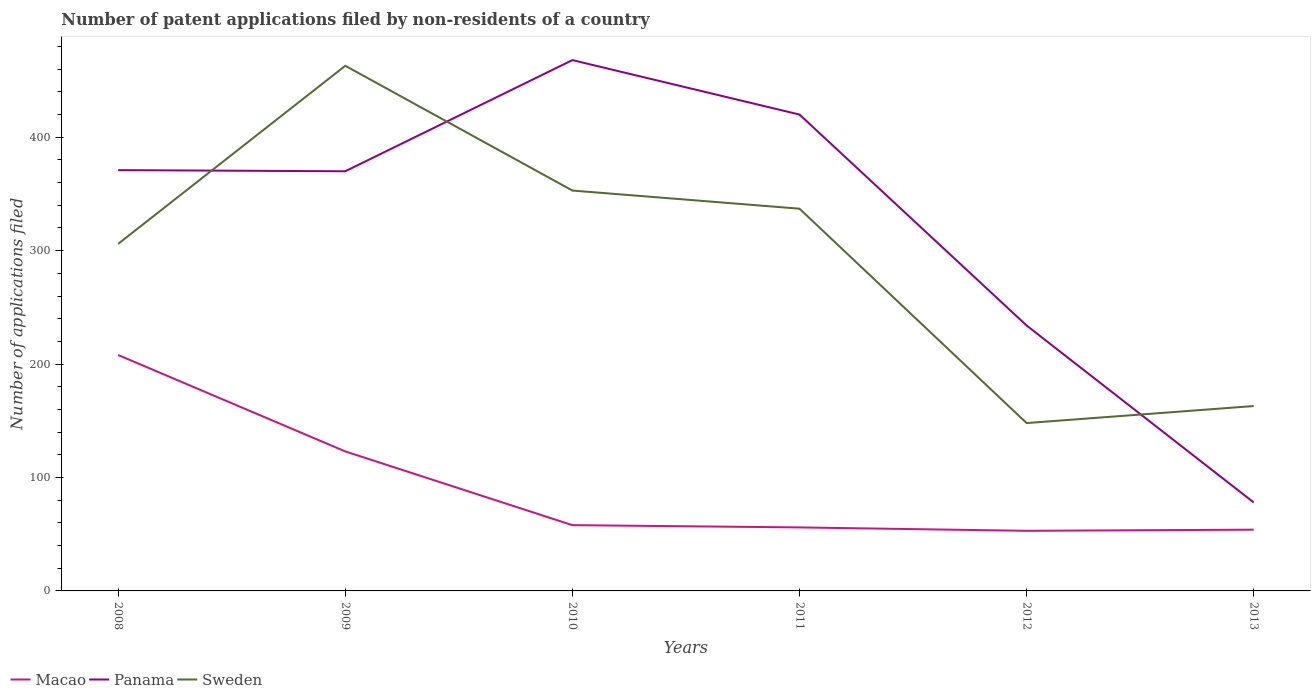Is the number of lines equal to the number of legend labels?
Offer a very short reply. Yes. Across all years, what is the maximum number of applications filed in Panama?
Offer a very short reply. 78. What is the total number of applications filed in Sweden in the graph?
Provide a short and direct response. 16. What is the difference between the highest and the second highest number of applications filed in Sweden?
Your answer should be very brief. 315. What is the difference between the highest and the lowest number of applications filed in Sweden?
Your answer should be compact. 4. How many years are there in the graph?
Your answer should be very brief. 6. Are the values on the major ticks of Y-axis written in scientific E-notation?
Make the answer very short. No. Does the graph contain any zero values?
Give a very brief answer. No. Where does the legend appear in the graph?
Provide a succinct answer. Bottom left. What is the title of the graph?
Offer a terse response. Number of patent applications filed by non-residents of a country. Does "Latvia" appear as one of the legend labels in the graph?
Give a very brief answer. No. What is the label or title of the Y-axis?
Ensure brevity in your answer.  Number of applications filed. What is the Number of applications filed of Macao in 2008?
Your response must be concise. 208. What is the Number of applications filed in Panama in 2008?
Provide a succinct answer. 371. What is the Number of applications filed of Sweden in 2008?
Make the answer very short. 306. What is the Number of applications filed of Macao in 2009?
Offer a terse response. 123. What is the Number of applications filed of Panama in 2009?
Your answer should be compact. 370. What is the Number of applications filed in Sweden in 2009?
Provide a succinct answer. 463. What is the Number of applications filed in Macao in 2010?
Offer a very short reply. 58. What is the Number of applications filed in Panama in 2010?
Your answer should be very brief. 468. What is the Number of applications filed of Sweden in 2010?
Ensure brevity in your answer.  353. What is the Number of applications filed in Panama in 2011?
Ensure brevity in your answer.  420. What is the Number of applications filed in Sweden in 2011?
Your answer should be very brief. 337. What is the Number of applications filed of Macao in 2012?
Provide a short and direct response. 53. What is the Number of applications filed in Panama in 2012?
Ensure brevity in your answer.  234. What is the Number of applications filed of Sweden in 2012?
Your answer should be very brief. 148. What is the Number of applications filed in Macao in 2013?
Make the answer very short. 54. What is the Number of applications filed of Sweden in 2013?
Your answer should be compact. 163. Across all years, what is the maximum Number of applications filed in Macao?
Provide a short and direct response. 208. Across all years, what is the maximum Number of applications filed in Panama?
Keep it short and to the point. 468. Across all years, what is the maximum Number of applications filed in Sweden?
Your answer should be compact. 463. Across all years, what is the minimum Number of applications filed of Sweden?
Offer a terse response. 148. What is the total Number of applications filed of Macao in the graph?
Your response must be concise. 552. What is the total Number of applications filed in Panama in the graph?
Give a very brief answer. 1941. What is the total Number of applications filed in Sweden in the graph?
Give a very brief answer. 1770. What is the difference between the Number of applications filed in Panama in 2008 and that in 2009?
Your answer should be very brief. 1. What is the difference between the Number of applications filed of Sweden in 2008 and that in 2009?
Ensure brevity in your answer.  -157. What is the difference between the Number of applications filed in Macao in 2008 and that in 2010?
Provide a succinct answer. 150. What is the difference between the Number of applications filed of Panama in 2008 and that in 2010?
Offer a very short reply. -97. What is the difference between the Number of applications filed of Sweden in 2008 and that in 2010?
Make the answer very short. -47. What is the difference between the Number of applications filed of Macao in 2008 and that in 2011?
Provide a succinct answer. 152. What is the difference between the Number of applications filed of Panama in 2008 and that in 2011?
Provide a short and direct response. -49. What is the difference between the Number of applications filed of Sweden in 2008 and that in 2011?
Offer a very short reply. -31. What is the difference between the Number of applications filed of Macao in 2008 and that in 2012?
Give a very brief answer. 155. What is the difference between the Number of applications filed of Panama in 2008 and that in 2012?
Make the answer very short. 137. What is the difference between the Number of applications filed in Sweden in 2008 and that in 2012?
Provide a short and direct response. 158. What is the difference between the Number of applications filed of Macao in 2008 and that in 2013?
Your answer should be compact. 154. What is the difference between the Number of applications filed of Panama in 2008 and that in 2013?
Offer a terse response. 293. What is the difference between the Number of applications filed in Sweden in 2008 and that in 2013?
Your answer should be very brief. 143. What is the difference between the Number of applications filed in Macao in 2009 and that in 2010?
Your response must be concise. 65. What is the difference between the Number of applications filed of Panama in 2009 and that in 2010?
Provide a short and direct response. -98. What is the difference between the Number of applications filed in Sweden in 2009 and that in 2010?
Keep it short and to the point. 110. What is the difference between the Number of applications filed in Macao in 2009 and that in 2011?
Provide a short and direct response. 67. What is the difference between the Number of applications filed of Panama in 2009 and that in 2011?
Your response must be concise. -50. What is the difference between the Number of applications filed of Sweden in 2009 and that in 2011?
Provide a succinct answer. 126. What is the difference between the Number of applications filed in Macao in 2009 and that in 2012?
Offer a very short reply. 70. What is the difference between the Number of applications filed of Panama in 2009 and that in 2012?
Give a very brief answer. 136. What is the difference between the Number of applications filed in Sweden in 2009 and that in 2012?
Your answer should be very brief. 315. What is the difference between the Number of applications filed in Macao in 2009 and that in 2013?
Provide a succinct answer. 69. What is the difference between the Number of applications filed of Panama in 2009 and that in 2013?
Your answer should be very brief. 292. What is the difference between the Number of applications filed of Sweden in 2009 and that in 2013?
Your answer should be compact. 300. What is the difference between the Number of applications filed of Macao in 2010 and that in 2011?
Your answer should be compact. 2. What is the difference between the Number of applications filed in Panama in 2010 and that in 2011?
Keep it short and to the point. 48. What is the difference between the Number of applications filed of Macao in 2010 and that in 2012?
Your response must be concise. 5. What is the difference between the Number of applications filed in Panama in 2010 and that in 2012?
Ensure brevity in your answer.  234. What is the difference between the Number of applications filed in Sweden in 2010 and that in 2012?
Give a very brief answer. 205. What is the difference between the Number of applications filed in Panama in 2010 and that in 2013?
Your answer should be very brief. 390. What is the difference between the Number of applications filed of Sweden in 2010 and that in 2013?
Your answer should be compact. 190. What is the difference between the Number of applications filed of Macao in 2011 and that in 2012?
Offer a very short reply. 3. What is the difference between the Number of applications filed of Panama in 2011 and that in 2012?
Keep it short and to the point. 186. What is the difference between the Number of applications filed in Sweden in 2011 and that in 2012?
Give a very brief answer. 189. What is the difference between the Number of applications filed of Macao in 2011 and that in 2013?
Offer a terse response. 2. What is the difference between the Number of applications filed of Panama in 2011 and that in 2013?
Your answer should be compact. 342. What is the difference between the Number of applications filed in Sweden in 2011 and that in 2013?
Keep it short and to the point. 174. What is the difference between the Number of applications filed of Macao in 2012 and that in 2013?
Offer a terse response. -1. What is the difference between the Number of applications filed of Panama in 2012 and that in 2013?
Provide a short and direct response. 156. What is the difference between the Number of applications filed in Sweden in 2012 and that in 2013?
Your answer should be very brief. -15. What is the difference between the Number of applications filed of Macao in 2008 and the Number of applications filed of Panama in 2009?
Give a very brief answer. -162. What is the difference between the Number of applications filed in Macao in 2008 and the Number of applications filed in Sweden in 2009?
Provide a succinct answer. -255. What is the difference between the Number of applications filed of Panama in 2008 and the Number of applications filed of Sweden in 2009?
Offer a terse response. -92. What is the difference between the Number of applications filed in Macao in 2008 and the Number of applications filed in Panama in 2010?
Provide a short and direct response. -260. What is the difference between the Number of applications filed in Macao in 2008 and the Number of applications filed in Sweden in 2010?
Keep it short and to the point. -145. What is the difference between the Number of applications filed of Macao in 2008 and the Number of applications filed of Panama in 2011?
Your answer should be compact. -212. What is the difference between the Number of applications filed in Macao in 2008 and the Number of applications filed in Sweden in 2011?
Make the answer very short. -129. What is the difference between the Number of applications filed in Panama in 2008 and the Number of applications filed in Sweden in 2011?
Provide a succinct answer. 34. What is the difference between the Number of applications filed in Panama in 2008 and the Number of applications filed in Sweden in 2012?
Give a very brief answer. 223. What is the difference between the Number of applications filed in Macao in 2008 and the Number of applications filed in Panama in 2013?
Your response must be concise. 130. What is the difference between the Number of applications filed in Macao in 2008 and the Number of applications filed in Sweden in 2013?
Offer a terse response. 45. What is the difference between the Number of applications filed of Panama in 2008 and the Number of applications filed of Sweden in 2013?
Provide a short and direct response. 208. What is the difference between the Number of applications filed of Macao in 2009 and the Number of applications filed of Panama in 2010?
Your response must be concise. -345. What is the difference between the Number of applications filed of Macao in 2009 and the Number of applications filed of Sweden in 2010?
Offer a terse response. -230. What is the difference between the Number of applications filed in Panama in 2009 and the Number of applications filed in Sweden in 2010?
Your answer should be very brief. 17. What is the difference between the Number of applications filed in Macao in 2009 and the Number of applications filed in Panama in 2011?
Your response must be concise. -297. What is the difference between the Number of applications filed in Macao in 2009 and the Number of applications filed in Sweden in 2011?
Your answer should be compact. -214. What is the difference between the Number of applications filed of Panama in 2009 and the Number of applications filed of Sweden in 2011?
Ensure brevity in your answer.  33. What is the difference between the Number of applications filed of Macao in 2009 and the Number of applications filed of Panama in 2012?
Keep it short and to the point. -111. What is the difference between the Number of applications filed of Panama in 2009 and the Number of applications filed of Sweden in 2012?
Your answer should be compact. 222. What is the difference between the Number of applications filed in Macao in 2009 and the Number of applications filed in Panama in 2013?
Your answer should be very brief. 45. What is the difference between the Number of applications filed of Macao in 2009 and the Number of applications filed of Sweden in 2013?
Your response must be concise. -40. What is the difference between the Number of applications filed of Panama in 2009 and the Number of applications filed of Sweden in 2013?
Make the answer very short. 207. What is the difference between the Number of applications filed of Macao in 2010 and the Number of applications filed of Panama in 2011?
Make the answer very short. -362. What is the difference between the Number of applications filed of Macao in 2010 and the Number of applications filed of Sweden in 2011?
Give a very brief answer. -279. What is the difference between the Number of applications filed of Panama in 2010 and the Number of applications filed of Sweden in 2011?
Provide a succinct answer. 131. What is the difference between the Number of applications filed in Macao in 2010 and the Number of applications filed in Panama in 2012?
Your answer should be compact. -176. What is the difference between the Number of applications filed in Macao in 2010 and the Number of applications filed in Sweden in 2012?
Offer a terse response. -90. What is the difference between the Number of applications filed of Panama in 2010 and the Number of applications filed of Sweden in 2012?
Give a very brief answer. 320. What is the difference between the Number of applications filed of Macao in 2010 and the Number of applications filed of Panama in 2013?
Give a very brief answer. -20. What is the difference between the Number of applications filed of Macao in 2010 and the Number of applications filed of Sweden in 2013?
Keep it short and to the point. -105. What is the difference between the Number of applications filed in Panama in 2010 and the Number of applications filed in Sweden in 2013?
Provide a short and direct response. 305. What is the difference between the Number of applications filed in Macao in 2011 and the Number of applications filed in Panama in 2012?
Keep it short and to the point. -178. What is the difference between the Number of applications filed in Macao in 2011 and the Number of applications filed in Sweden in 2012?
Ensure brevity in your answer.  -92. What is the difference between the Number of applications filed in Panama in 2011 and the Number of applications filed in Sweden in 2012?
Provide a succinct answer. 272. What is the difference between the Number of applications filed of Macao in 2011 and the Number of applications filed of Panama in 2013?
Your answer should be very brief. -22. What is the difference between the Number of applications filed in Macao in 2011 and the Number of applications filed in Sweden in 2013?
Make the answer very short. -107. What is the difference between the Number of applications filed in Panama in 2011 and the Number of applications filed in Sweden in 2013?
Offer a very short reply. 257. What is the difference between the Number of applications filed in Macao in 2012 and the Number of applications filed in Sweden in 2013?
Your answer should be very brief. -110. What is the average Number of applications filed in Macao per year?
Offer a very short reply. 92. What is the average Number of applications filed in Panama per year?
Your answer should be very brief. 323.5. What is the average Number of applications filed of Sweden per year?
Your response must be concise. 295. In the year 2008, what is the difference between the Number of applications filed in Macao and Number of applications filed in Panama?
Provide a succinct answer. -163. In the year 2008, what is the difference between the Number of applications filed in Macao and Number of applications filed in Sweden?
Provide a short and direct response. -98. In the year 2009, what is the difference between the Number of applications filed in Macao and Number of applications filed in Panama?
Provide a succinct answer. -247. In the year 2009, what is the difference between the Number of applications filed in Macao and Number of applications filed in Sweden?
Your answer should be compact. -340. In the year 2009, what is the difference between the Number of applications filed of Panama and Number of applications filed of Sweden?
Make the answer very short. -93. In the year 2010, what is the difference between the Number of applications filed of Macao and Number of applications filed of Panama?
Give a very brief answer. -410. In the year 2010, what is the difference between the Number of applications filed in Macao and Number of applications filed in Sweden?
Offer a very short reply. -295. In the year 2010, what is the difference between the Number of applications filed of Panama and Number of applications filed of Sweden?
Your answer should be very brief. 115. In the year 2011, what is the difference between the Number of applications filed in Macao and Number of applications filed in Panama?
Provide a short and direct response. -364. In the year 2011, what is the difference between the Number of applications filed of Macao and Number of applications filed of Sweden?
Give a very brief answer. -281. In the year 2011, what is the difference between the Number of applications filed in Panama and Number of applications filed in Sweden?
Make the answer very short. 83. In the year 2012, what is the difference between the Number of applications filed of Macao and Number of applications filed of Panama?
Your response must be concise. -181. In the year 2012, what is the difference between the Number of applications filed of Macao and Number of applications filed of Sweden?
Offer a very short reply. -95. In the year 2012, what is the difference between the Number of applications filed in Panama and Number of applications filed in Sweden?
Offer a terse response. 86. In the year 2013, what is the difference between the Number of applications filed in Macao and Number of applications filed in Panama?
Keep it short and to the point. -24. In the year 2013, what is the difference between the Number of applications filed of Macao and Number of applications filed of Sweden?
Offer a very short reply. -109. In the year 2013, what is the difference between the Number of applications filed in Panama and Number of applications filed in Sweden?
Make the answer very short. -85. What is the ratio of the Number of applications filed of Macao in 2008 to that in 2009?
Provide a succinct answer. 1.69. What is the ratio of the Number of applications filed in Panama in 2008 to that in 2009?
Provide a succinct answer. 1. What is the ratio of the Number of applications filed in Sweden in 2008 to that in 2009?
Provide a succinct answer. 0.66. What is the ratio of the Number of applications filed of Macao in 2008 to that in 2010?
Provide a short and direct response. 3.59. What is the ratio of the Number of applications filed of Panama in 2008 to that in 2010?
Offer a very short reply. 0.79. What is the ratio of the Number of applications filed of Sweden in 2008 to that in 2010?
Offer a very short reply. 0.87. What is the ratio of the Number of applications filed of Macao in 2008 to that in 2011?
Make the answer very short. 3.71. What is the ratio of the Number of applications filed of Panama in 2008 to that in 2011?
Ensure brevity in your answer.  0.88. What is the ratio of the Number of applications filed in Sweden in 2008 to that in 2011?
Offer a very short reply. 0.91. What is the ratio of the Number of applications filed in Macao in 2008 to that in 2012?
Keep it short and to the point. 3.92. What is the ratio of the Number of applications filed of Panama in 2008 to that in 2012?
Make the answer very short. 1.59. What is the ratio of the Number of applications filed in Sweden in 2008 to that in 2012?
Make the answer very short. 2.07. What is the ratio of the Number of applications filed of Macao in 2008 to that in 2013?
Your response must be concise. 3.85. What is the ratio of the Number of applications filed in Panama in 2008 to that in 2013?
Your answer should be very brief. 4.76. What is the ratio of the Number of applications filed of Sweden in 2008 to that in 2013?
Your answer should be compact. 1.88. What is the ratio of the Number of applications filed in Macao in 2009 to that in 2010?
Provide a short and direct response. 2.12. What is the ratio of the Number of applications filed of Panama in 2009 to that in 2010?
Make the answer very short. 0.79. What is the ratio of the Number of applications filed in Sweden in 2009 to that in 2010?
Keep it short and to the point. 1.31. What is the ratio of the Number of applications filed of Macao in 2009 to that in 2011?
Provide a succinct answer. 2.2. What is the ratio of the Number of applications filed of Panama in 2009 to that in 2011?
Keep it short and to the point. 0.88. What is the ratio of the Number of applications filed of Sweden in 2009 to that in 2011?
Your answer should be compact. 1.37. What is the ratio of the Number of applications filed of Macao in 2009 to that in 2012?
Offer a very short reply. 2.32. What is the ratio of the Number of applications filed in Panama in 2009 to that in 2012?
Ensure brevity in your answer.  1.58. What is the ratio of the Number of applications filed of Sweden in 2009 to that in 2012?
Make the answer very short. 3.13. What is the ratio of the Number of applications filed in Macao in 2009 to that in 2013?
Offer a very short reply. 2.28. What is the ratio of the Number of applications filed in Panama in 2009 to that in 2013?
Your response must be concise. 4.74. What is the ratio of the Number of applications filed of Sweden in 2009 to that in 2013?
Your response must be concise. 2.84. What is the ratio of the Number of applications filed of Macao in 2010 to that in 2011?
Offer a terse response. 1.04. What is the ratio of the Number of applications filed in Panama in 2010 to that in 2011?
Your answer should be very brief. 1.11. What is the ratio of the Number of applications filed in Sweden in 2010 to that in 2011?
Offer a very short reply. 1.05. What is the ratio of the Number of applications filed in Macao in 2010 to that in 2012?
Offer a very short reply. 1.09. What is the ratio of the Number of applications filed of Sweden in 2010 to that in 2012?
Provide a succinct answer. 2.39. What is the ratio of the Number of applications filed of Macao in 2010 to that in 2013?
Your answer should be very brief. 1.07. What is the ratio of the Number of applications filed in Sweden in 2010 to that in 2013?
Offer a terse response. 2.17. What is the ratio of the Number of applications filed in Macao in 2011 to that in 2012?
Provide a succinct answer. 1.06. What is the ratio of the Number of applications filed in Panama in 2011 to that in 2012?
Give a very brief answer. 1.79. What is the ratio of the Number of applications filed of Sweden in 2011 to that in 2012?
Your response must be concise. 2.28. What is the ratio of the Number of applications filed of Macao in 2011 to that in 2013?
Make the answer very short. 1.04. What is the ratio of the Number of applications filed of Panama in 2011 to that in 2013?
Provide a succinct answer. 5.38. What is the ratio of the Number of applications filed of Sweden in 2011 to that in 2013?
Make the answer very short. 2.07. What is the ratio of the Number of applications filed in Macao in 2012 to that in 2013?
Your response must be concise. 0.98. What is the ratio of the Number of applications filed in Sweden in 2012 to that in 2013?
Keep it short and to the point. 0.91. What is the difference between the highest and the second highest Number of applications filed of Macao?
Your answer should be very brief. 85. What is the difference between the highest and the second highest Number of applications filed of Panama?
Your answer should be compact. 48. What is the difference between the highest and the second highest Number of applications filed of Sweden?
Ensure brevity in your answer.  110. What is the difference between the highest and the lowest Number of applications filed of Macao?
Your response must be concise. 155. What is the difference between the highest and the lowest Number of applications filed of Panama?
Provide a short and direct response. 390. What is the difference between the highest and the lowest Number of applications filed in Sweden?
Your answer should be very brief. 315. 